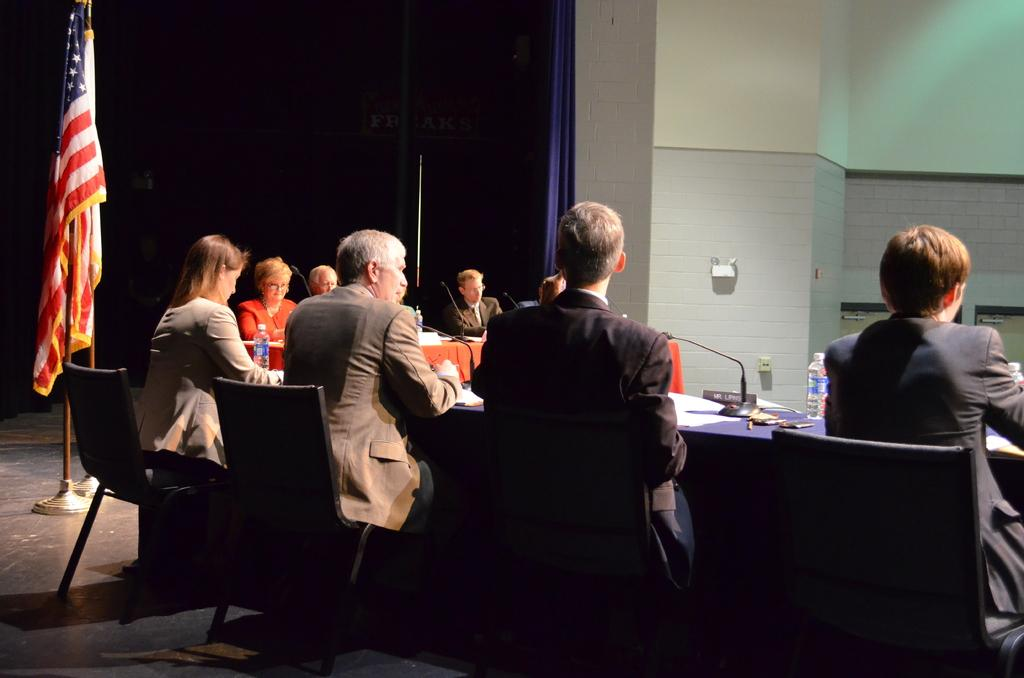What are the people in the image doing? The people in the image are seated on chairs. What can be seen in the background of the image? Flags are visible in the image. What items are on the table in the image? Papers, water bottles, and microphones are present on the table in the image. What is located on the side in the image? There is a cloth on the side in the image. How many cherries are on the table in the image? There are no cherries present on the table in the image. Can you see any ants crawling on the people in the image? There are no ants visible in the image. 